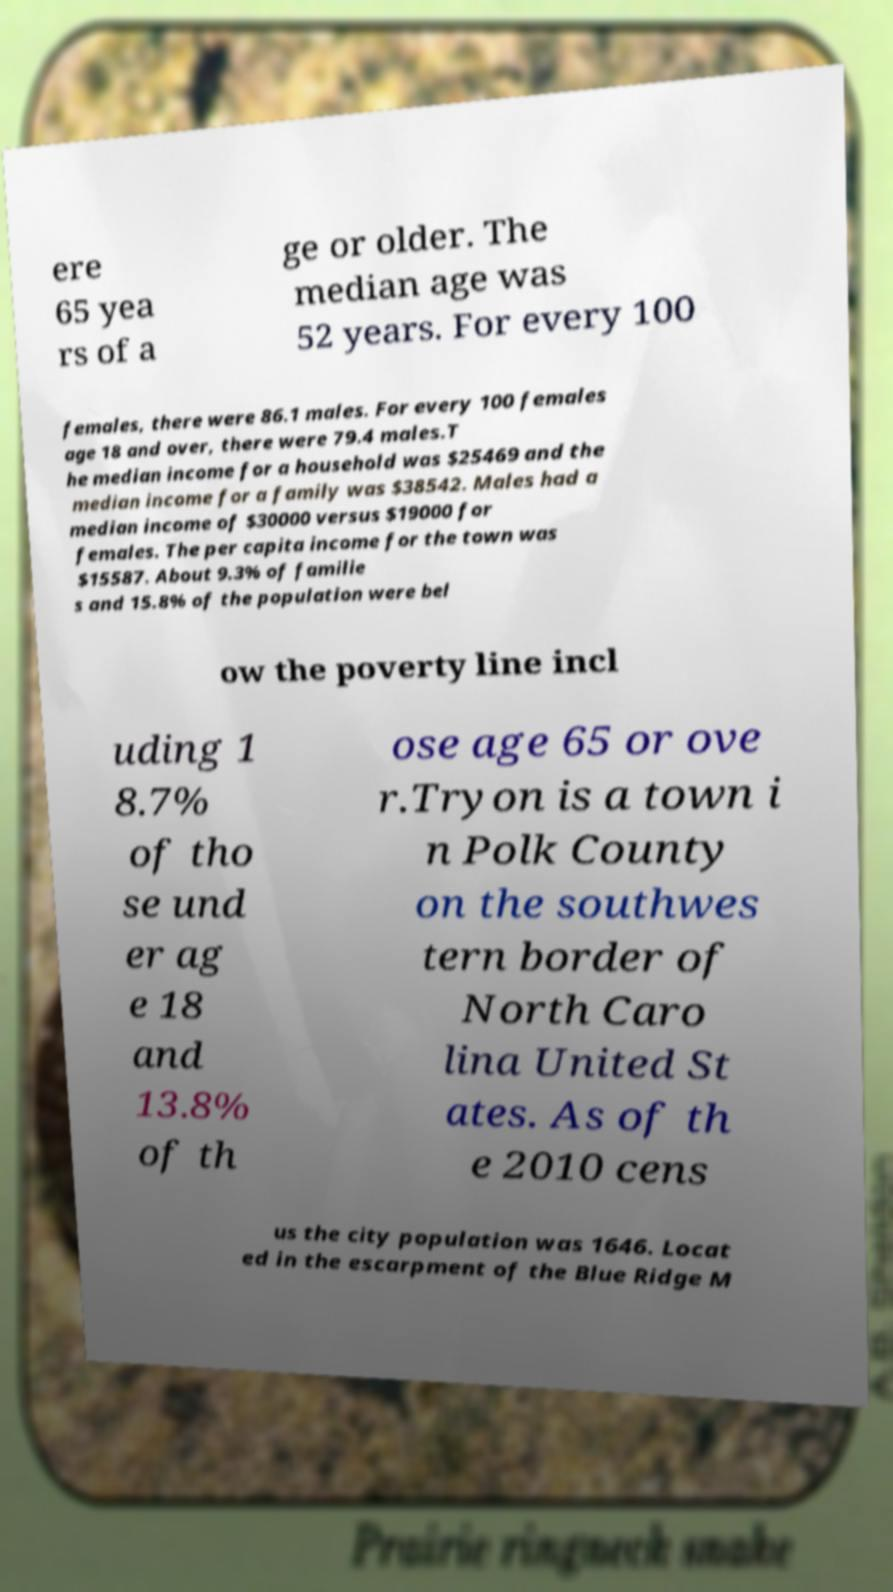Can you read and provide the text displayed in the image?This photo seems to have some interesting text. Can you extract and type it out for me? ere 65 yea rs of a ge or older. The median age was 52 years. For every 100 females, there were 86.1 males. For every 100 females age 18 and over, there were 79.4 males.T he median income for a household was $25469 and the median income for a family was $38542. Males had a median income of $30000 versus $19000 for females. The per capita income for the town was $15587. About 9.3% of familie s and 15.8% of the population were bel ow the poverty line incl uding 1 8.7% of tho se und er ag e 18 and 13.8% of th ose age 65 or ove r.Tryon is a town i n Polk County on the southwes tern border of North Caro lina United St ates. As of th e 2010 cens us the city population was 1646. Locat ed in the escarpment of the Blue Ridge M 